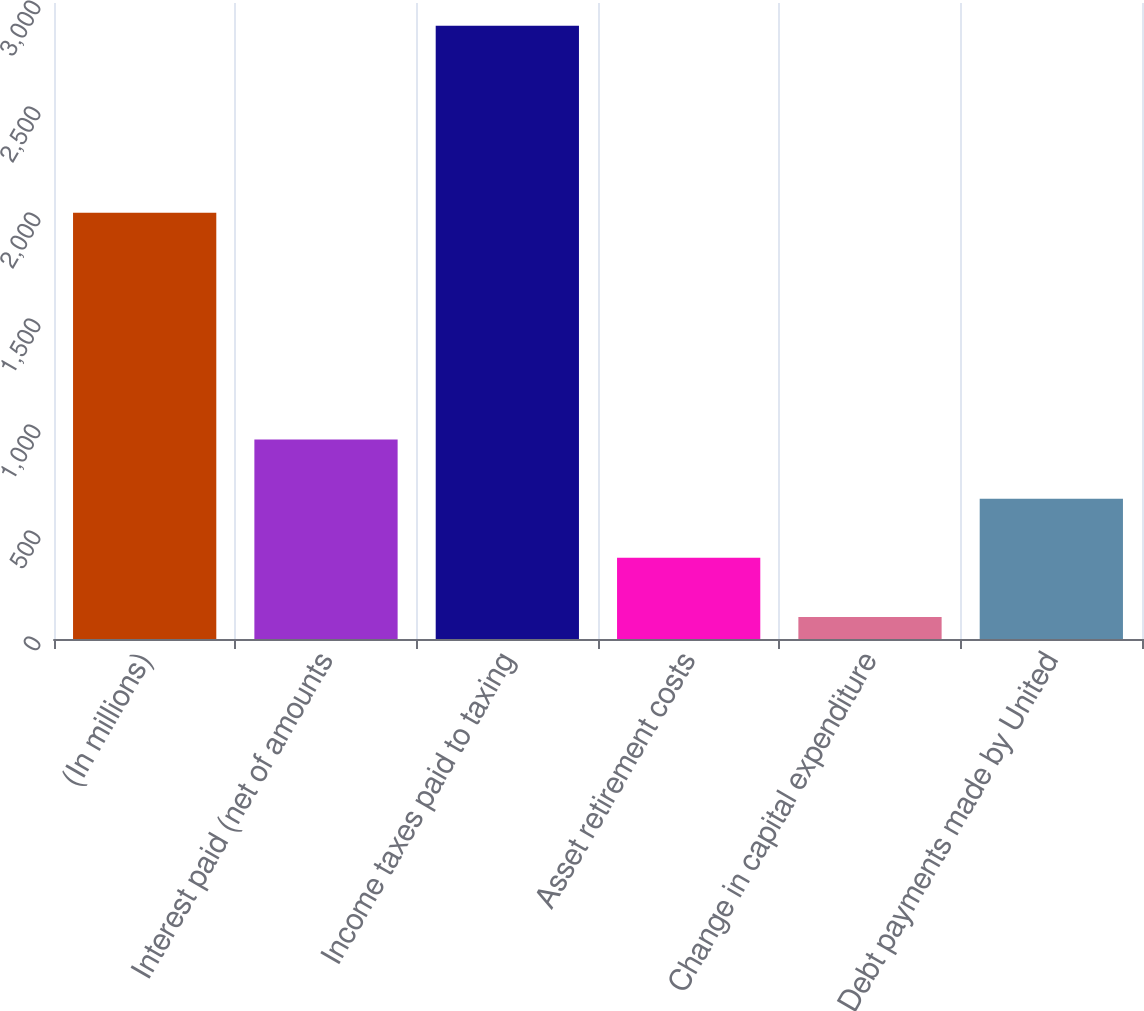Convert chart to OTSL. <chart><loc_0><loc_0><loc_500><loc_500><bar_chart><fcel>(In millions)<fcel>Interest paid (net of amounts<fcel>Income taxes paid to taxing<fcel>Asset retirement costs<fcel>Change in capital expenditure<fcel>Debt payments made by United<nl><fcel>2011<fcel>940.7<fcel>2893<fcel>382.9<fcel>104<fcel>661.8<nl></chart> 